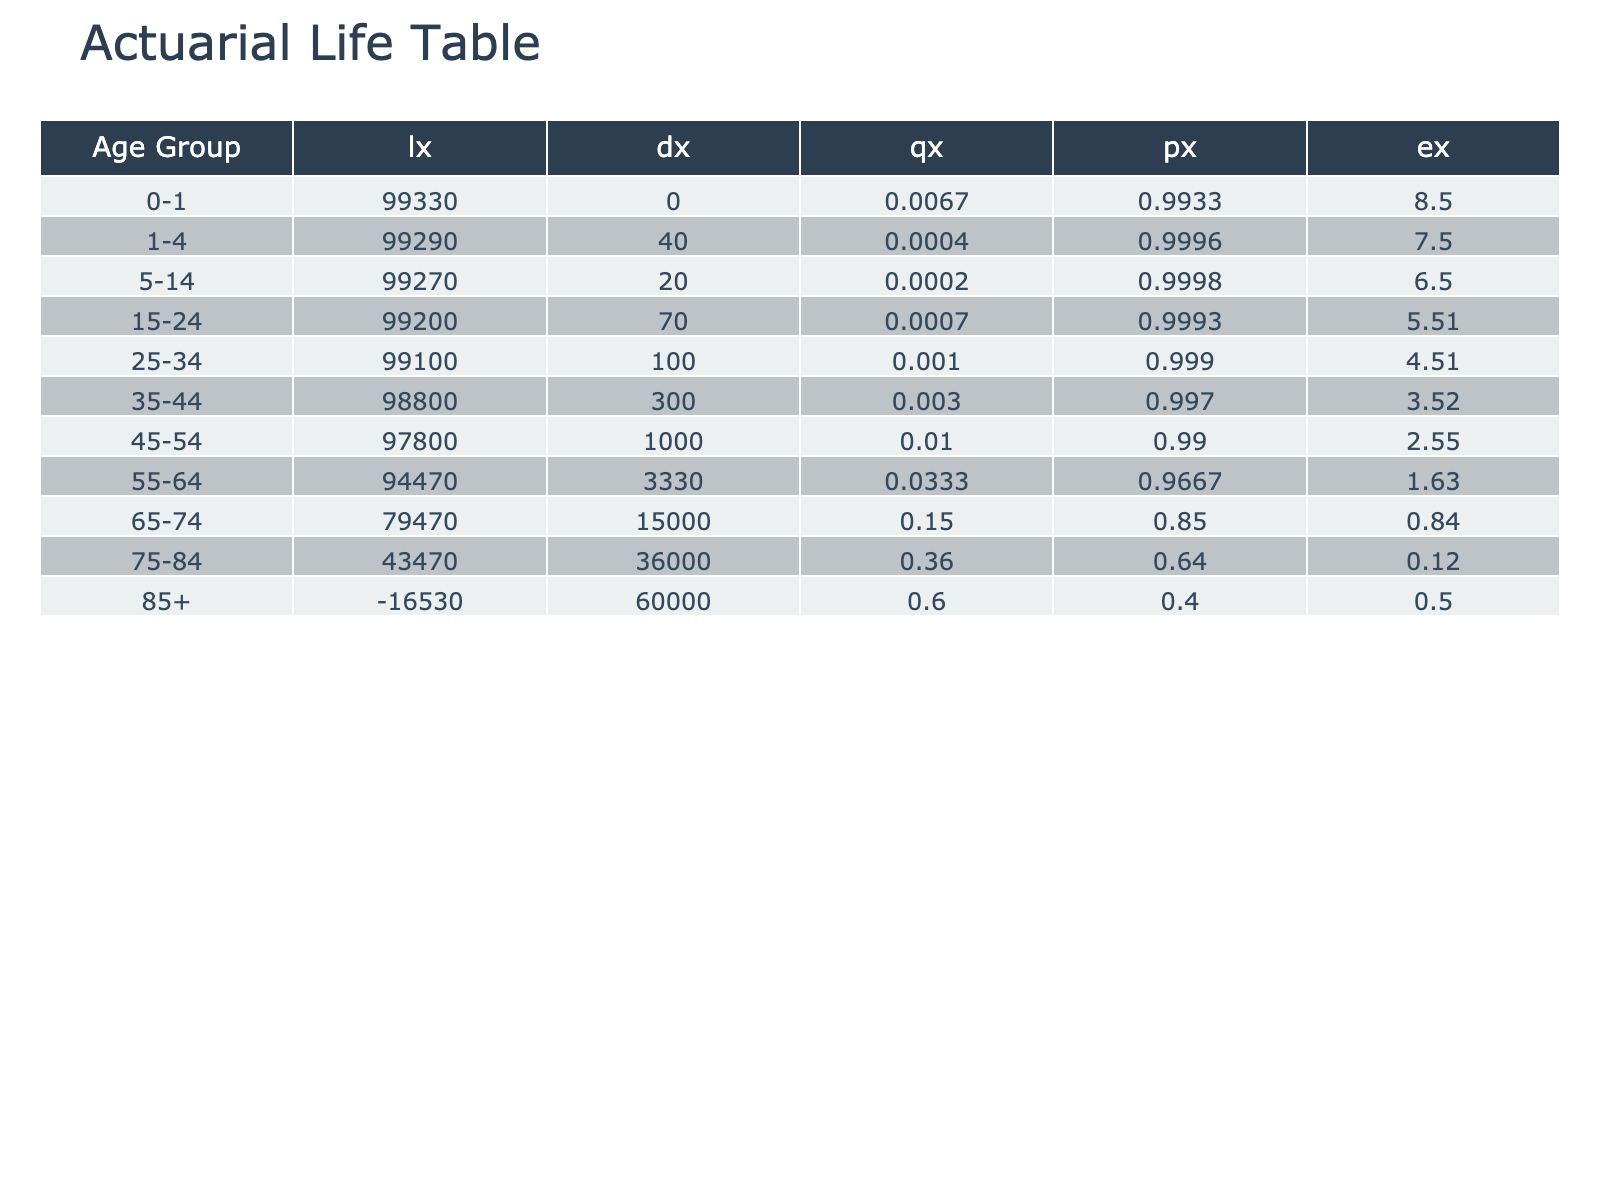What is the mortality rate for the age group 55-64? The table lists the mortality rates for each age group. For the age group 55-64, the mortality rate is provided directly in the table as 0.0333.
Answer: 0.0333 Which age group has the highest number of deaths? By analyzing the "Number of Deaths" column in the table, the age group 75-84 has 90,000 deaths, which is greater than the deaths reported for all other age groups.
Answer: 75-84 What is the total number of deaths across all age groups? To find the total number of deaths, we sum the "Number of Deaths" for each age group: 2000 + 500 + 300 + 700 + 1200 + 3000 + 8000 + 20000 + 60000 + 90000 + 60000 = 191,800.
Answer: 191800 Is the mortality rate for the age group 0-1 higher than that for 1-4? The mortality rate for age group 0-1 is 0.0067, while for 1-4 it is 0.0004. Since 0.0067 is greater than 0.0004, the statement is true.
Answer: Yes What is the average mortality rate for the age groups 15-24 and 25-34? The mortality rates for these age groups are 0.0007 and 0.0010, respectively. To find the average, we sum these rates (0.0007 + 0.0010 = 0.0017) and divide by the number of groups (2), giving us an average of 0.00085.
Answer: 0.00085 Which age group has the highest mortality rate and what is that rate? By examining the "Mortality Rate" column, the 85+ age group has the highest rate of 0.6000 compared to other age groups.
Answer: 85+, 0.6000 What is the difference in the number of deaths between the age groups 45-54 and 55-64? The number of deaths for age group 45-54 is 8,000 and for 55-64 is 20,000. The difference is 20,000 - 8,000 = 12,000.
Answer: 12000 Is the population of the age group 25-34 greater than that of 65-74? The population of age group 25-34 is 1,200,000, while for 65-74 it is 400,000. Since 1,200,000 is greater than 400,000, the statement is true.
Answer: Yes How many age groups have a mortality rate of 0.01 or higher? Reviewing the "Mortality Rate" column, the age groups 45-54, 55-64, 65-74, 75-84, and 85+ have rates of 0.0100, 0.0333, 0.1500, 0.3600, and 0.6000 respectively. This totals to five groups.
Answer: 5 